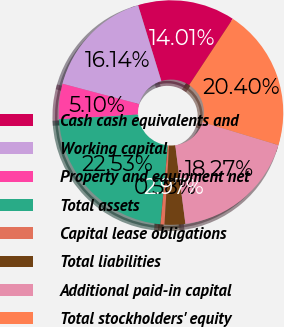Convert chart to OTSL. <chart><loc_0><loc_0><loc_500><loc_500><pie_chart><fcel>Cash cash equivalents and<fcel>Working capital<fcel>Property and equipment net<fcel>Total assets<fcel>Capital lease obligations<fcel>Total liabilities<fcel>Additional paid-in capital<fcel>Total stockholders' equity<nl><fcel>14.01%<fcel>16.14%<fcel>5.1%<fcel>22.53%<fcel>0.58%<fcel>2.97%<fcel>18.27%<fcel>20.4%<nl></chart> 